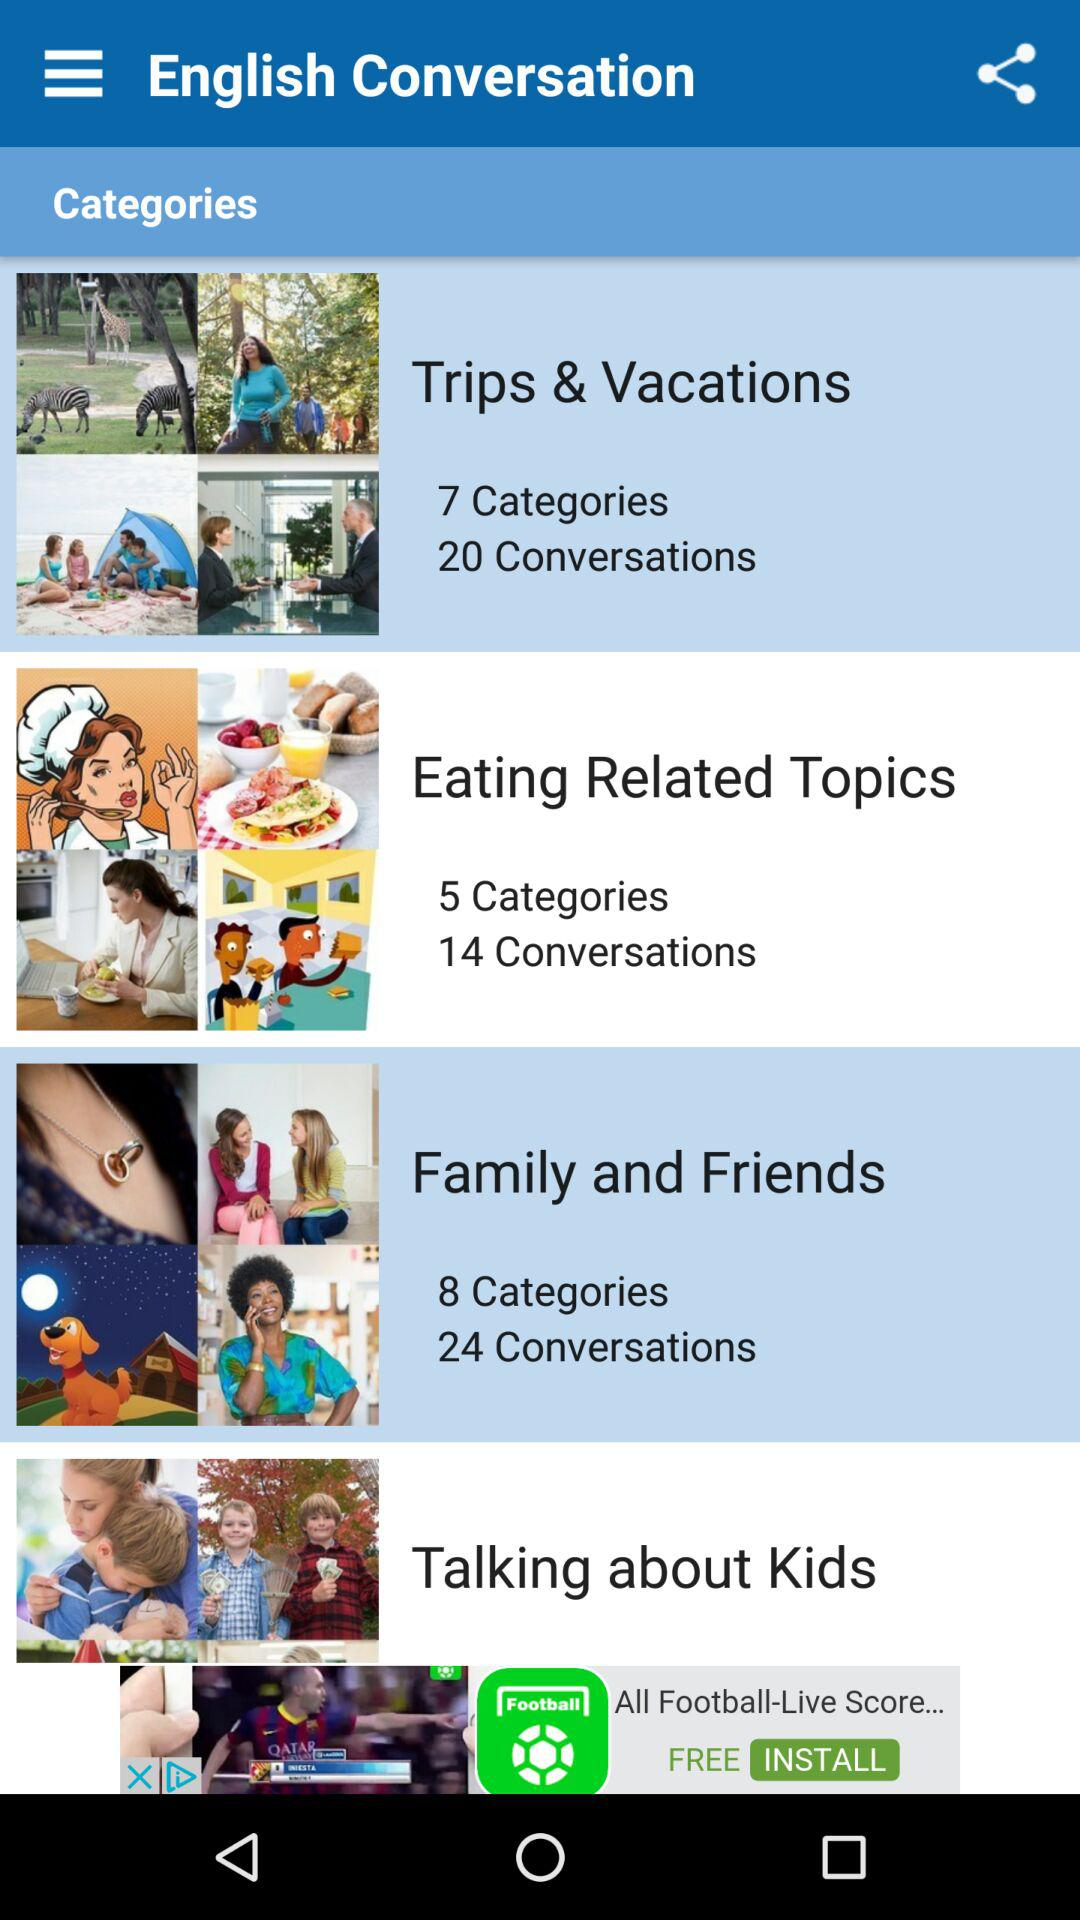How many conversations are there on "Eating Related Topics"? There are 14 conversations. 